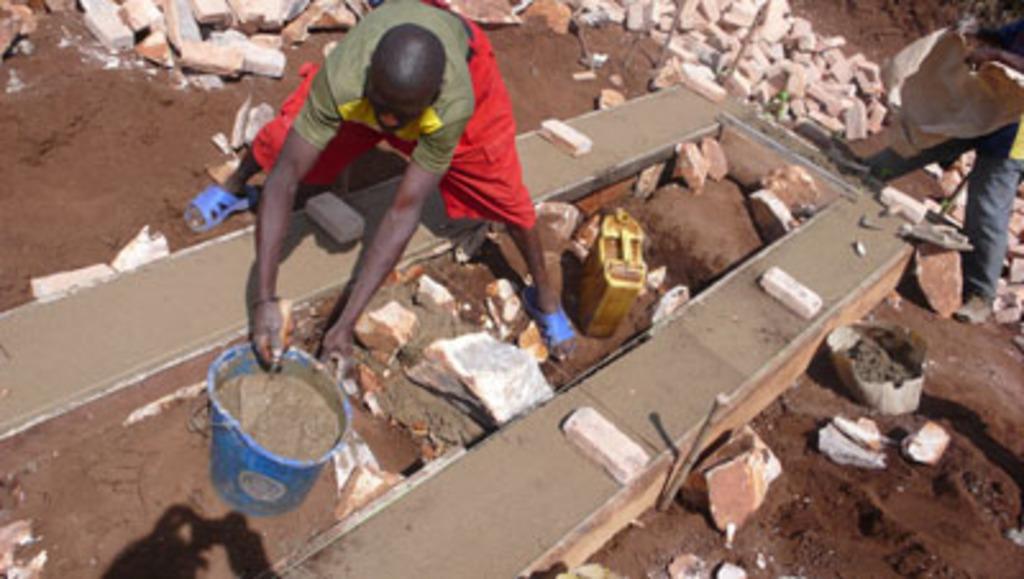How would you summarize this image in a sentence or two? In this picture we can see people on the ground, here we can see a wall, bricks, bucket, water can, soil and some objects. 